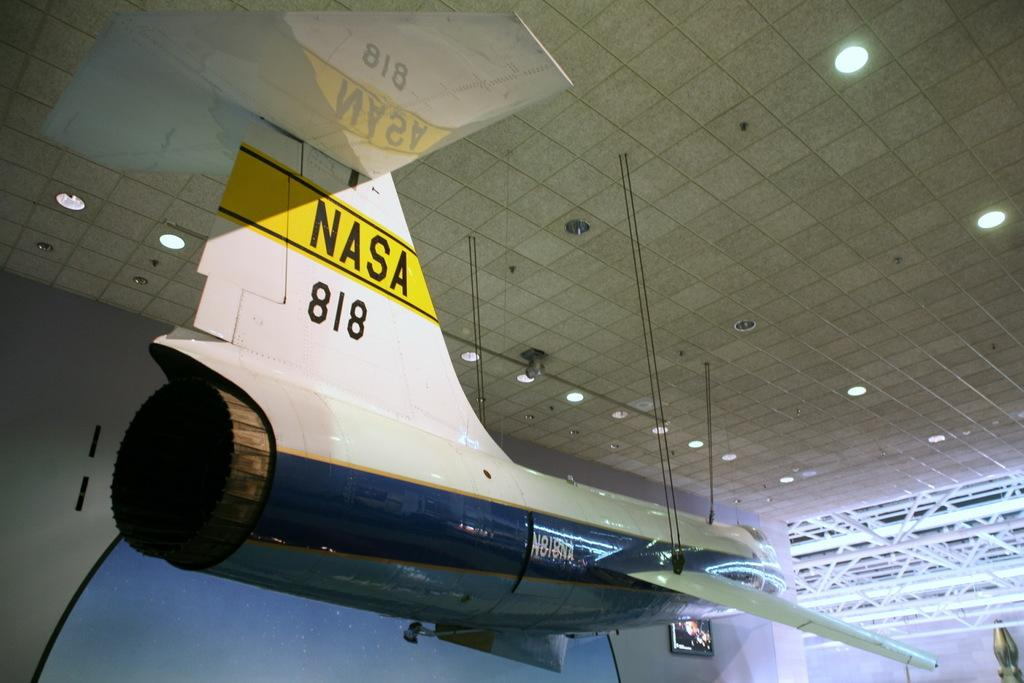<image>
Present a compact description of the photo's key features. A model airplane with NASA written on the tail 